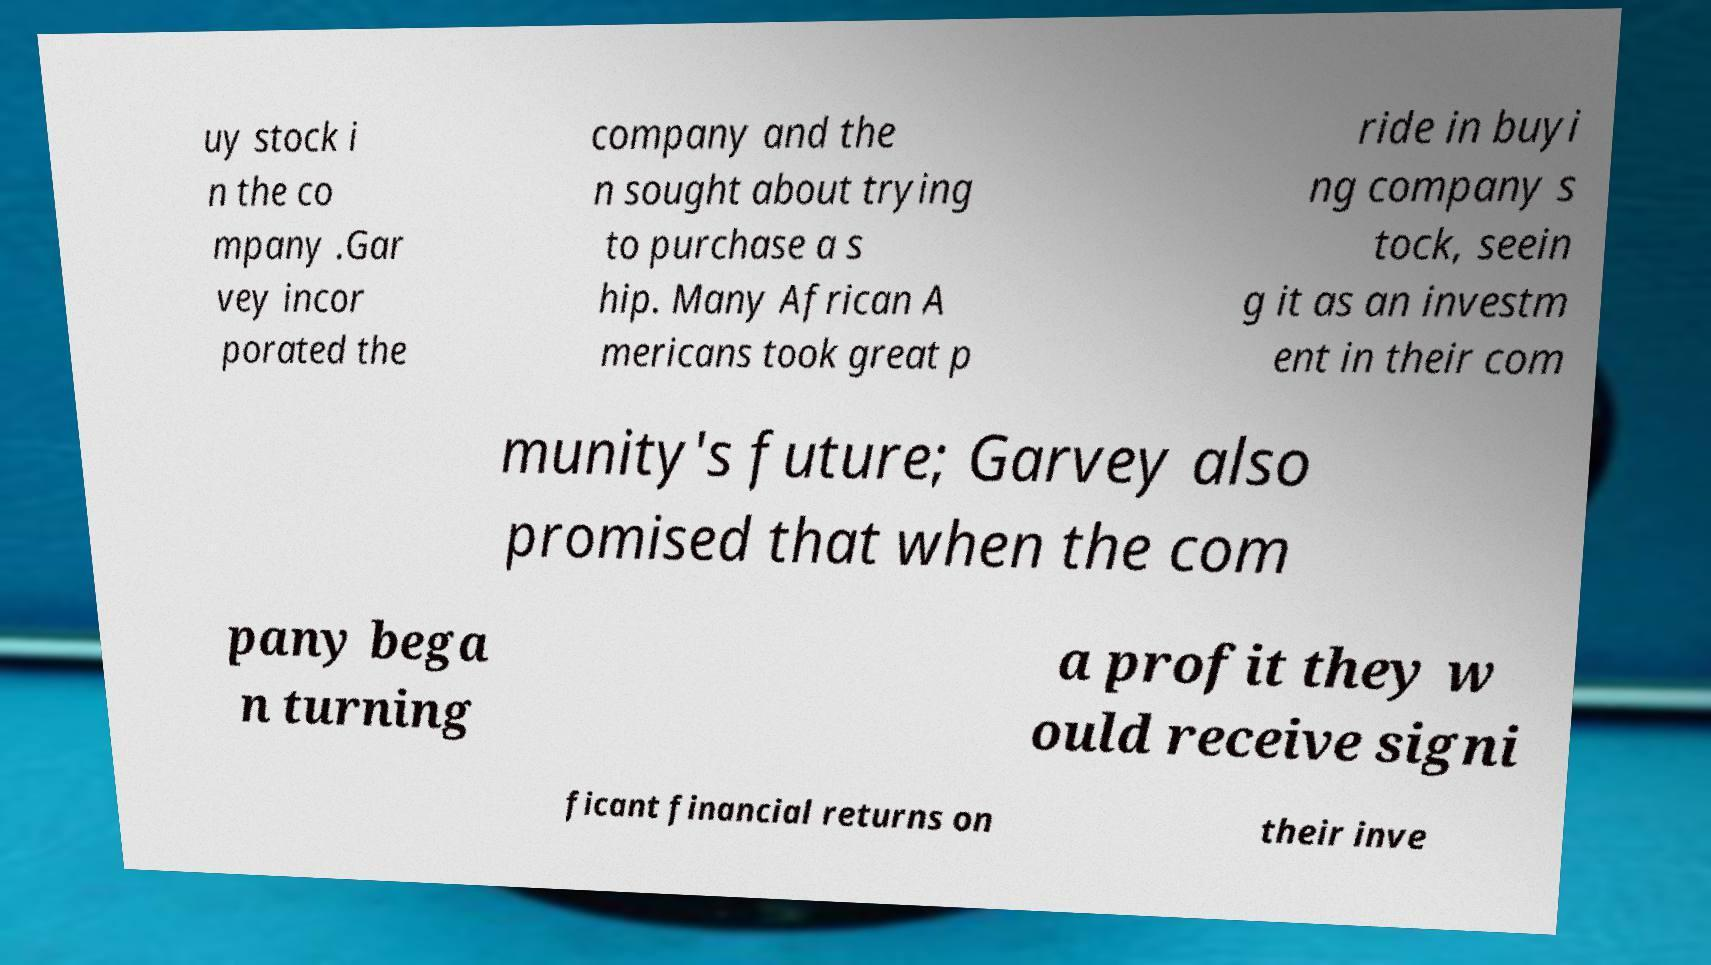There's text embedded in this image that I need extracted. Can you transcribe it verbatim? uy stock i n the co mpany .Gar vey incor porated the company and the n sought about trying to purchase a s hip. Many African A mericans took great p ride in buyi ng company s tock, seein g it as an investm ent in their com munity's future; Garvey also promised that when the com pany bega n turning a profit they w ould receive signi ficant financial returns on their inve 